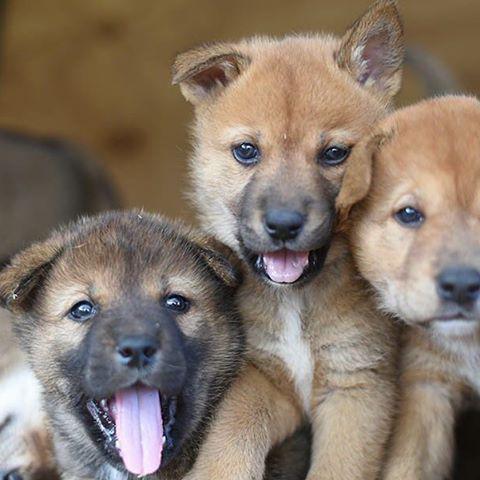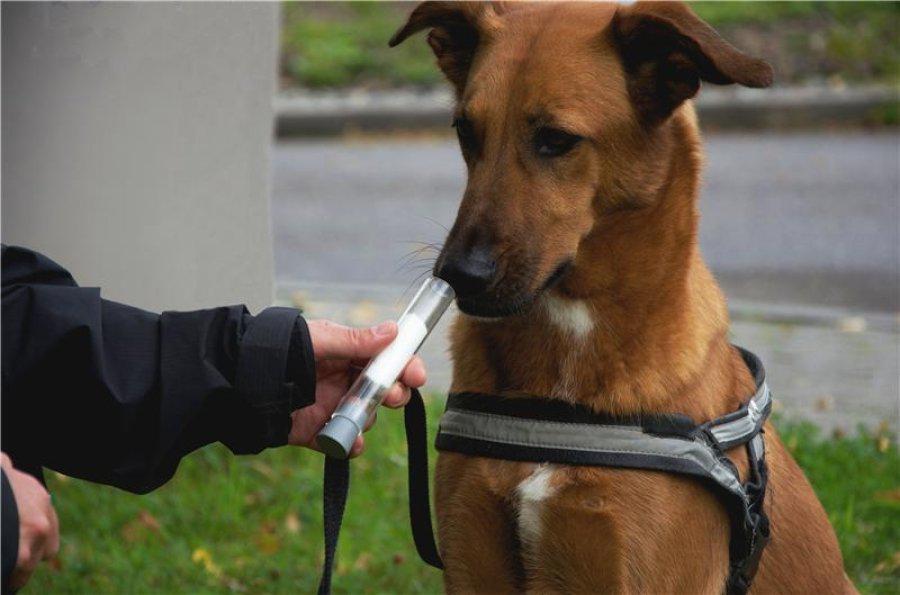The first image is the image on the left, the second image is the image on the right. Considering the images on both sides, is "The combined images include at least two dingo pups and at least one adult dingo." valid? Answer yes or no. Yes. The first image is the image on the left, the second image is the image on the right. For the images shown, is this caption "A brown dog with large pointy ears is looking directly forward." true? Answer yes or no. No. 